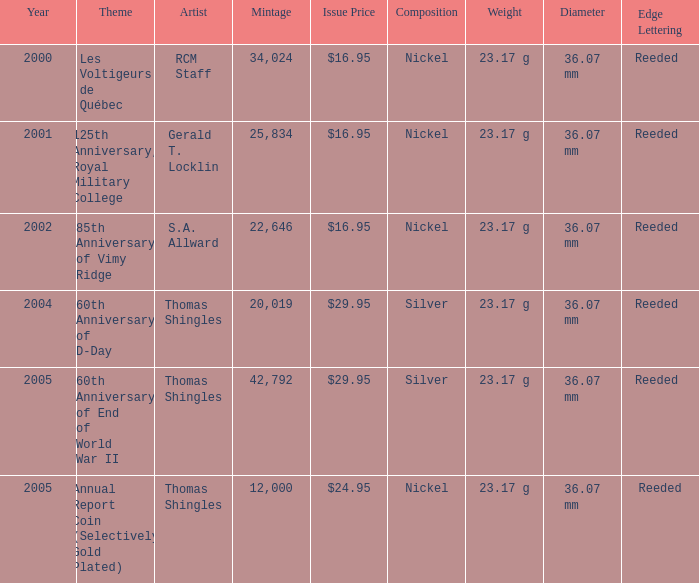What year was S.A. Allward's theme that had an issue price of $16.95 released? 2002.0. 